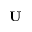<formula> <loc_0><loc_0><loc_500><loc_500>U</formula> 